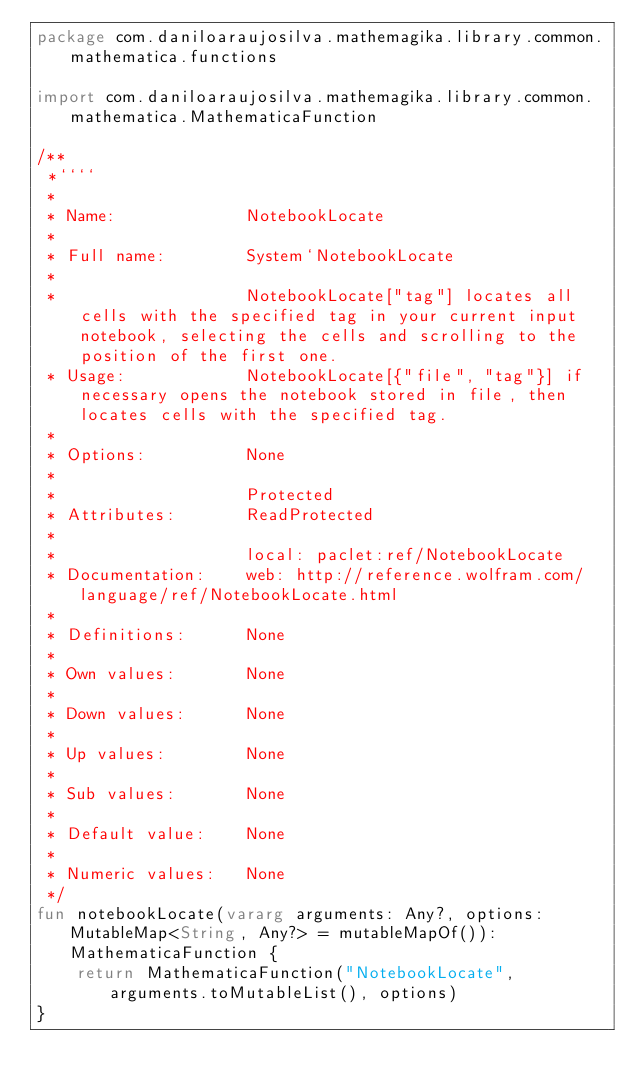<code> <loc_0><loc_0><loc_500><loc_500><_Kotlin_>package com.daniloaraujosilva.mathemagika.library.common.mathematica.functions

import com.daniloaraujosilva.mathemagika.library.common.mathematica.MathematicaFunction

/**
 *````
 *
 * Name:             NotebookLocate
 *
 * Full name:        System`NotebookLocate
 *
 *                   NotebookLocate["tag"] locates all cells with the specified tag in your current input notebook, selecting the cells and scrolling to the position of the first one.
 * Usage:            NotebookLocate[{"file", "tag"}] if necessary opens the notebook stored in file, then locates cells with the specified tag.
 *
 * Options:          None
 *
 *                   Protected
 * Attributes:       ReadProtected
 *
 *                   local: paclet:ref/NotebookLocate
 * Documentation:    web: http://reference.wolfram.com/language/ref/NotebookLocate.html
 *
 * Definitions:      None
 *
 * Own values:       None
 *
 * Down values:      None
 *
 * Up values:        None
 *
 * Sub values:       None
 *
 * Default value:    None
 *
 * Numeric values:   None
 */
fun notebookLocate(vararg arguments: Any?, options: MutableMap<String, Any?> = mutableMapOf()): MathematicaFunction {
	return MathematicaFunction("NotebookLocate", arguments.toMutableList(), options)
}
</code> 